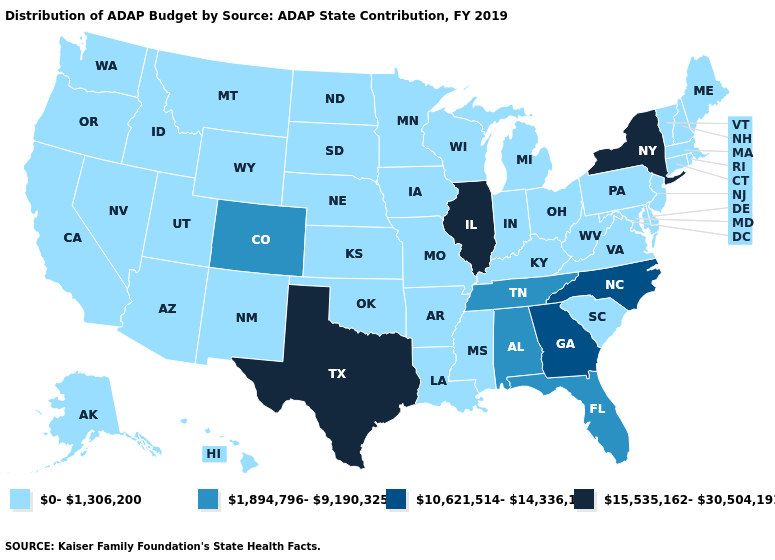What is the lowest value in the USA?
Write a very short answer. 0-1,306,200. What is the highest value in the USA?
Give a very brief answer. 15,535,162-30,504,191. What is the value of North Dakota?
Keep it brief. 0-1,306,200. What is the lowest value in the Northeast?
Quick response, please. 0-1,306,200. What is the highest value in states that border Wyoming?
Concise answer only. 1,894,796-9,190,325. What is the value of South Carolina?
Answer briefly. 0-1,306,200. Does Illinois have the lowest value in the USA?
Give a very brief answer. No. What is the lowest value in the MidWest?
Keep it brief. 0-1,306,200. Which states have the lowest value in the USA?
Keep it brief. Alaska, Arizona, Arkansas, California, Connecticut, Delaware, Hawaii, Idaho, Indiana, Iowa, Kansas, Kentucky, Louisiana, Maine, Maryland, Massachusetts, Michigan, Minnesota, Mississippi, Missouri, Montana, Nebraska, Nevada, New Hampshire, New Jersey, New Mexico, North Dakota, Ohio, Oklahoma, Oregon, Pennsylvania, Rhode Island, South Carolina, South Dakota, Utah, Vermont, Virginia, Washington, West Virginia, Wisconsin, Wyoming. Among the states that border Ohio , which have the highest value?
Answer briefly. Indiana, Kentucky, Michigan, Pennsylvania, West Virginia. Name the states that have a value in the range 15,535,162-30,504,191?
Answer briefly. Illinois, New York, Texas. Name the states that have a value in the range 10,621,514-14,336,118?
Keep it brief. Georgia, North Carolina. Name the states that have a value in the range 10,621,514-14,336,118?
Keep it brief. Georgia, North Carolina. Name the states that have a value in the range 15,535,162-30,504,191?
Keep it brief. Illinois, New York, Texas. What is the value of South Carolina?
Keep it brief. 0-1,306,200. 